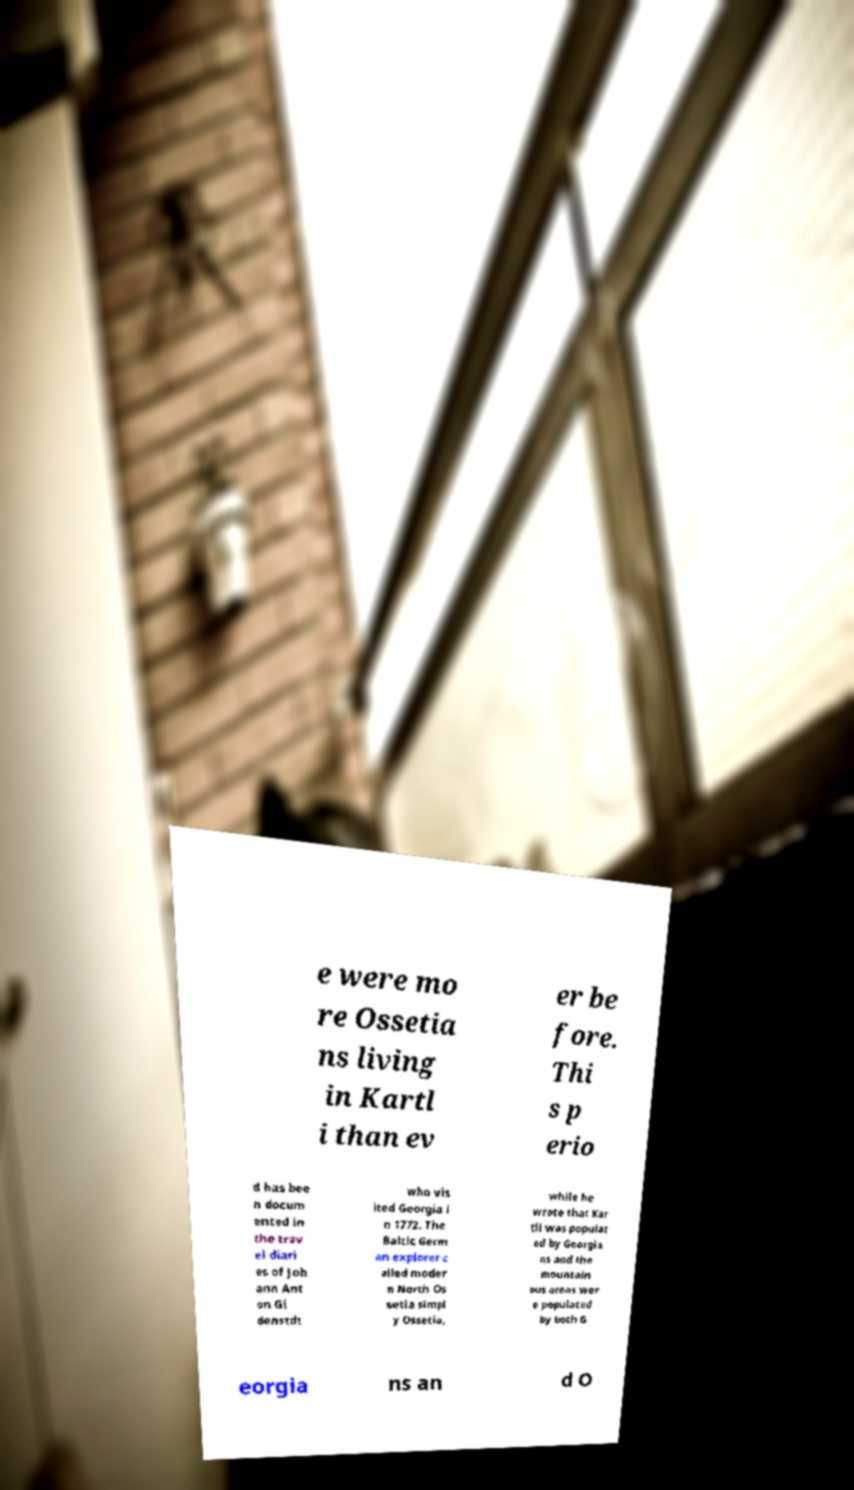There's text embedded in this image that I need extracted. Can you transcribe it verbatim? e were mo re Ossetia ns living in Kartl i than ev er be fore. Thi s p erio d has bee n docum ented in the trav el diari es of Joh ann Ant on Gl denstdt who vis ited Georgia i n 1772. The Baltic Germ an explorer c alled moder n North Os setia simpl y Ossetia, while he wrote that Kar tli was populat ed by Georgia ns and the mountain ous areas wer e populated by both G eorgia ns an d O 